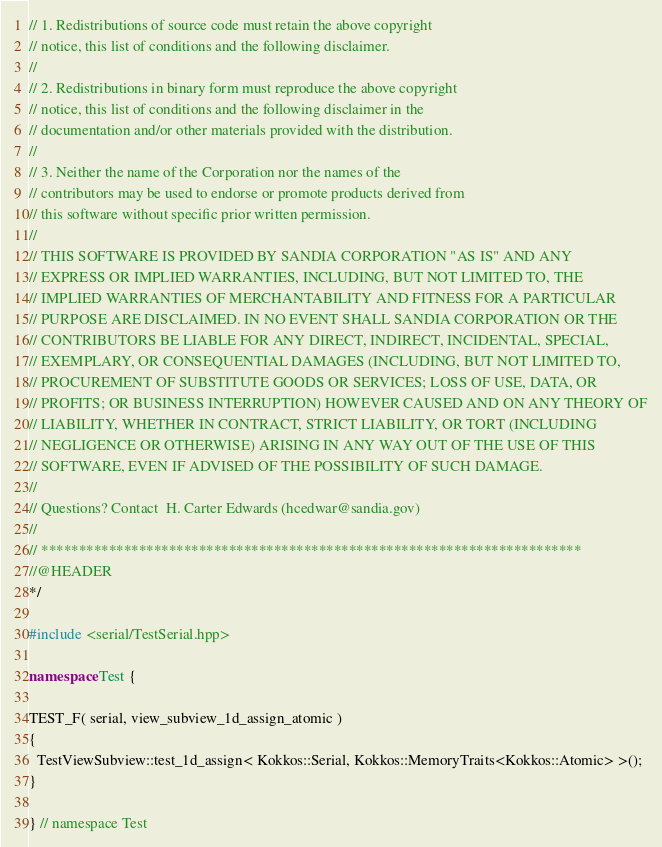Convert code to text. <code><loc_0><loc_0><loc_500><loc_500><_C++_>// 1. Redistributions of source code must retain the above copyright
// notice, this list of conditions and the following disclaimer.
//
// 2. Redistributions in binary form must reproduce the above copyright
// notice, this list of conditions and the following disclaimer in the
// documentation and/or other materials provided with the distribution.
//
// 3. Neither the name of the Corporation nor the names of the
// contributors may be used to endorse or promote products derived from
// this software without specific prior written permission.
//
// THIS SOFTWARE IS PROVIDED BY SANDIA CORPORATION "AS IS" AND ANY
// EXPRESS OR IMPLIED WARRANTIES, INCLUDING, BUT NOT LIMITED TO, THE
// IMPLIED WARRANTIES OF MERCHANTABILITY AND FITNESS FOR A PARTICULAR
// PURPOSE ARE DISCLAIMED. IN NO EVENT SHALL SANDIA CORPORATION OR THE
// CONTRIBUTORS BE LIABLE FOR ANY DIRECT, INDIRECT, INCIDENTAL, SPECIAL,
// EXEMPLARY, OR CONSEQUENTIAL DAMAGES (INCLUDING, BUT NOT LIMITED TO,
// PROCUREMENT OF SUBSTITUTE GOODS OR SERVICES; LOSS OF USE, DATA, OR
// PROFITS; OR BUSINESS INTERRUPTION) HOWEVER CAUSED AND ON ANY THEORY OF
// LIABILITY, WHETHER IN CONTRACT, STRICT LIABILITY, OR TORT (INCLUDING
// NEGLIGENCE OR OTHERWISE) ARISING IN ANY WAY OUT OF THE USE OF THIS
// SOFTWARE, EVEN IF ADVISED OF THE POSSIBILITY OF SUCH DAMAGE.
//
// Questions? Contact  H. Carter Edwards (hcedwar@sandia.gov)
//
// ************************************************************************
//@HEADER
*/

#include <serial/TestSerial.hpp>

namespace Test {

TEST_F( serial, view_subview_1d_assign_atomic )
{
  TestViewSubview::test_1d_assign< Kokkos::Serial, Kokkos::MemoryTraits<Kokkos::Atomic> >();
}

} // namespace Test
</code> 